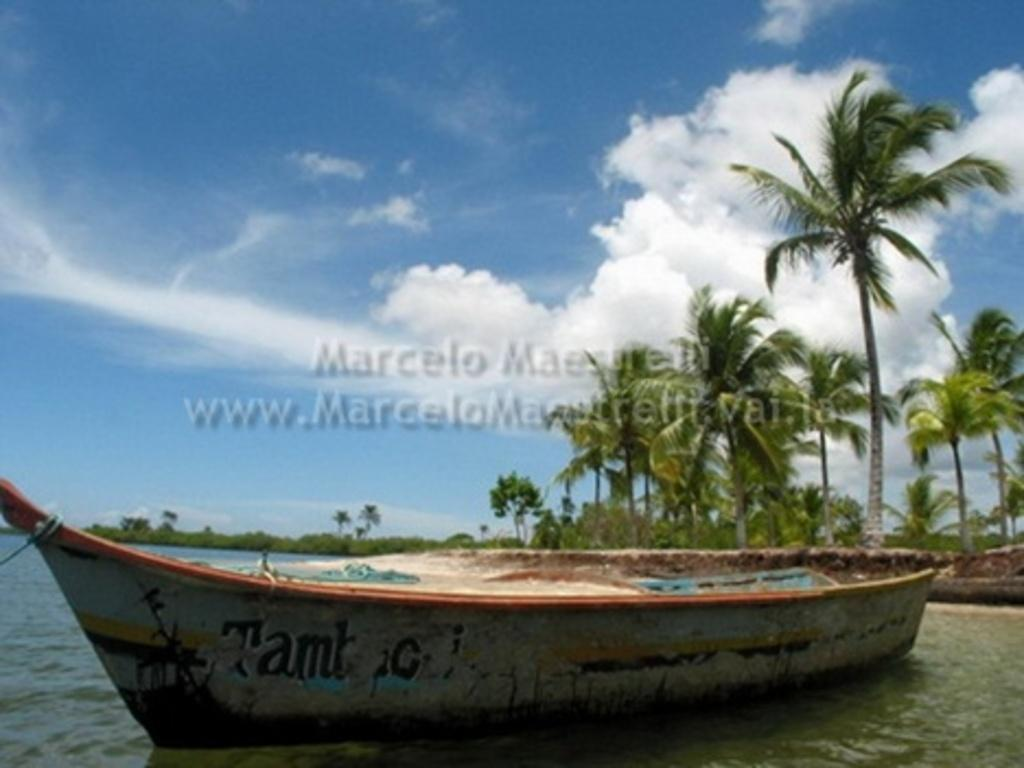What is located in the water in the image? There is a boat in the water in the image. What type of natural environment is visible in the image? There are trees visible in the image. How would you describe the sky in the image? The sky is blue and cloudy in the image. What can be seen in the middle of the picture? There is text in the middle of the picture. What type of crook is trying to steal the boat in the image? There is no crook or theft depicted in the image; it simply shows a boat in the water. Can you tell me how many flights are visible in the image? There are no flights or airplanes present in the image. 